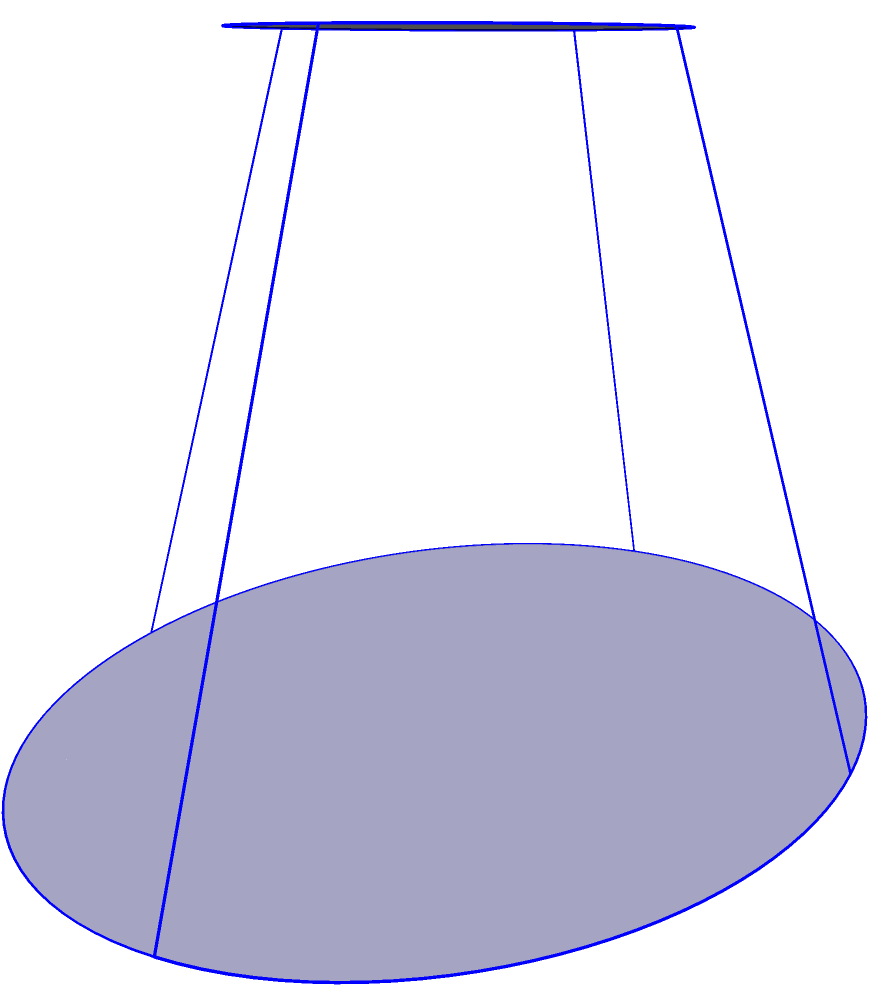You've been commissioned to create a mural featuring a famous boxer holding a unique truncated pyramid-shaped trophy. To accurately depict the trophy, you need to calculate its volume. The trophy's base is a rectangle measuring 8 cm by 6 cm, its top is a rectangle measuring 4 cm by 3 cm, and its height is 5 cm. What is the volume of this trophy in cubic centimeters? To calculate the volume of a truncated pyramid, we can use the following formula:

$$V = \frac{h}{3}(A_1 + A_2 + \sqrt{A_1A_2})$$

Where:
$V$ = Volume
$h$ = Height
$A_1$ = Area of the base
$A_2$ = Area of the top

Let's solve this step-by-step:

1) First, calculate the areas:
   $A_1 = 8 \times 6 = 48$ cm²
   $A_2 = 4 \times 3 = 12$ cm²

2) Now, let's substitute these values into the formula:
   $$V = \frac{5}{3}(48 + 12 + \sqrt{48 \times 12})$$

3) Simplify under the square root:
   $$V = \frac{5}{3}(48 + 12 + \sqrt{576})$$

4) Calculate the square root:
   $$V = \frac{5}{3}(48 + 12 + 24)$$

5) Sum the values inside the parentheses:
   $$V = \frac{5}{3}(84)$$

6) Multiply:
   $$V = 140$$ cm³

Therefore, the volume of the trophy is 140 cubic centimeters.
Answer: 140 cm³ 